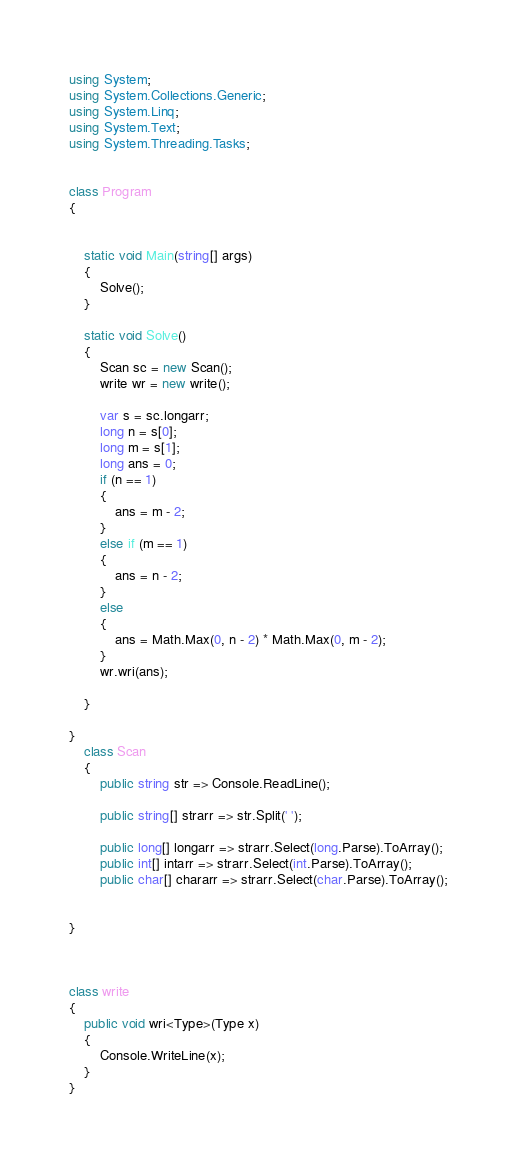<code> <loc_0><loc_0><loc_500><loc_500><_C#_>using System;
using System.Collections.Generic;
using System.Linq;
using System.Text;
using System.Threading.Tasks;


class Program
{


    static void Main(string[] args)
    {
        Solve();
    }

    static void Solve()
    {
        Scan sc = new Scan();
        write wr = new write();

        var s = sc.longarr;
        long n = s[0];
        long m = s[1];
        long ans = 0;
        if (n == 1)
        {
            ans = m - 2;
        }
        else if (m == 1)
        {
            ans = n - 2;
        }
        else
        {
            ans = Math.Max(0, n - 2) * Math.Max(0, m - 2);
        }
        wr.wri(ans);

    }

}
    class Scan
    {
        public string str => Console.ReadLine();

        public string[] strarr => str.Split(' ');

        public long[] longarr => strarr.Select(long.Parse).ToArray();
        public int[] intarr => strarr.Select(int.Parse).ToArray();
        public char[] chararr => strarr.Select(char.Parse).ToArray();


}



class write
{
    public void wri<Type>(Type x)
    {
        Console.WriteLine(x);
    }
}
</code> 